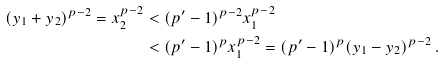Convert formula to latex. <formula><loc_0><loc_0><loc_500><loc_500>( y _ { 1 } + y _ { 2 } ) ^ { p - 2 } = x _ { 2 } ^ { p - 2 } & < ( p ^ { \prime } - 1 ) ^ { p - 2 } x _ { 1 } ^ { p - 2 } \\ & < ( p ^ { \prime } - 1 ) ^ { p } x _ { 1 } ^ { p - 2 } = ( p ^ { \prime } - 1 ) ^ { p } ( y _ { 1 } - y _ { 2 } ) ^ { p - 2 } \, .</formula> 